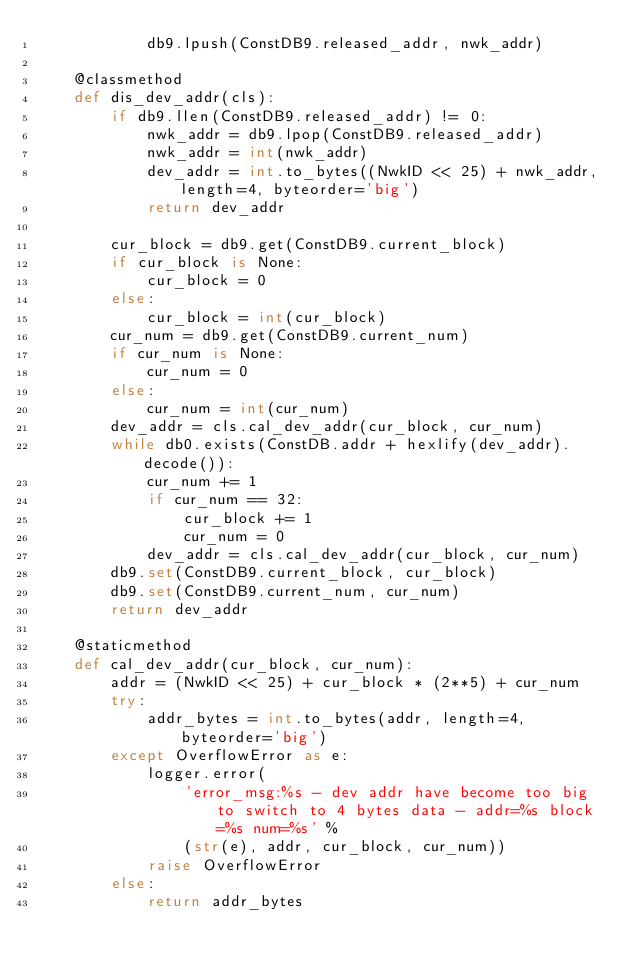Convert code to text. <code><loc_0><loc_0><loc_500><loc_500><_Python_>            db9.lpush(ConstDB9.released_addr, nwk_addr)

    @classmethod
    def dis_dev_addr(cls):
        if db9.llen(ConstDB9.released_addr) != 0:
            nwk_addr = db9.lpop(ConstDB9.released_addr)
            nwk_addr = int(nwk_addr)
            dev_addr = int.to_bytes((NwkID << 25) + nwk_addr, length=4, byteorder='big')
            return dev_addr

        cur_block = db9.get(ConstDB9.current_block)
        if cur_block is None:
            cur_block = 0
        else:
            cur_block = int(cur_block)
        cur_num = db9.get(ConstDB9.current_num)
        if cur_num is None:
            cur_num = 0
        else:
            cur_num = int(cur_num)
        dev_addr = cls.cal_dev_addr(cur_block, cur_num)
        while db0.exists(ConstDB.addr + hexlify(dev_addr).decode()):
            cur_num += 1
            if cur_num == 32:
                cur_block += 1
                cur_num = 0
            dev_addr = cls.cal_dev_addr(cur_block, cur_num)
        db9.set(ConstDB9.current_block, cur_block)
        db9.set(ConstDB9.current_num, cur_num)
        return dev_addr

    @staticmethod
    def cal_dev_addr(cur_block, cur_num):
        addr = (NwkID << 25) + cur_block * (2**5) + cur_num
        try:
            addr_bytes = int.to_bytes(addr, length=4, byteorder='big')
        except OverflowError as e:
            logger.error(
                'error_msg:%s - dev addr have become too big to switch to 4 bytes data - addr=%s block=%s num=%s' %
                (str(e), addr, cur_block, cur_num))
            raise OverflowError
        else:
            return addr_bytes


</code> 